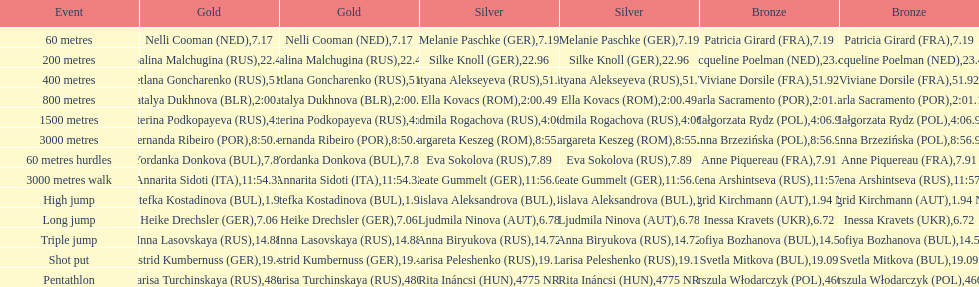How many german women won medals? 5. 